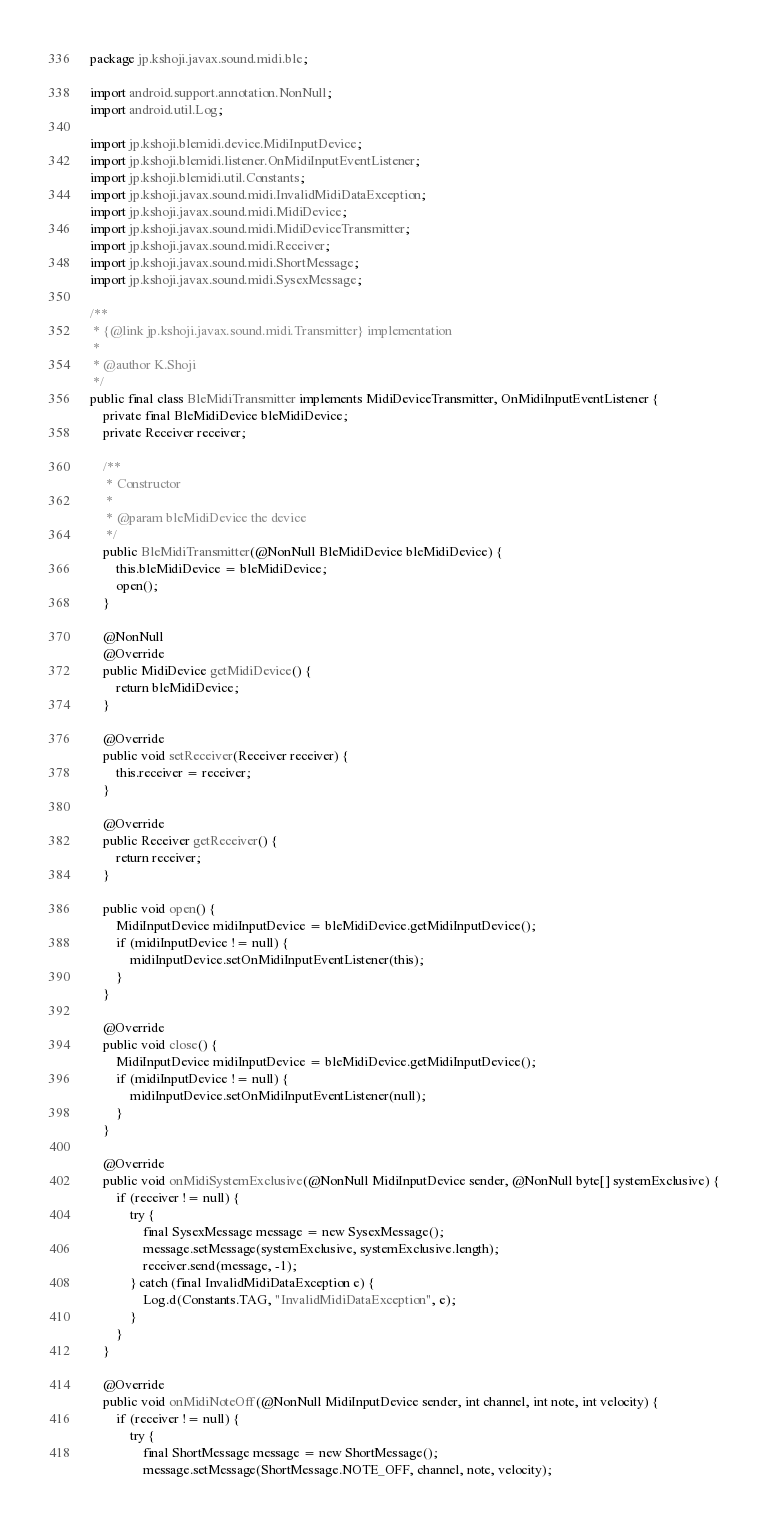Convert code to text. <code><loc_0><loc_0><loc_500><loc_500><_Java_>package jp.kshoji.javax.sound.midi.ble;

import android.support.annotation.NonNull;
import android.util.Log;

import jp.kshoji.blemidi.device.MidiInputDevice;
import jp.kshoji.blemidi.listener.OnMidiInputEventListener;
import jp.kshoji.blemidi.util.Constants;
import jp.kshoji.javax.sound.midi.InvalidMidiDataException;
import jp.kshoji.javax.sound.midi.MidiDevice;
import jp.kshoji.javax.sound.midi.MidiDeviceTransmitter;
import jp.kshoji.javax.sound.midi.Receiver;
import jp.kshoji.javax.sound.midi.ShortMessage;
import jp.kshoji.javax.sound.midi.SysexMessage;

/**
 * {@link jp.kshoji.javax.sound.midi.Transmitter} implementation
 *
 * @author K.Shoji
 */
public final class BleMidiTransmitter implements MidiDeviceTransmitter, OnMidiInputEventListener {
    private final BleMidiDevice bleMidiDevice;
    private Receiver receiver;

    /**
     * Constructor
     *
     * @param bleMidiDevice the device
     */
    public BleMidiTransmitter(@NonNull BleMidiDevice bleMidiDevice) {
        this.bleMidiDevice = bleMidiDevice;
        open();
    }

    @NonNull
    @Override
    public MidiDevice getMidiDevice() {
        return bleMidiDevice;
    }

    @Override
    public void setReceiver(Receiver receiver) {
        this.receiver = receiver;
    }

    @Override
    public Receiver getReceiver() {
        return receiver;
    }

    public void open() {
        MidiInputDevice midiInputDevice = bleMidiDevice.getMidiInputDevice();
        if (midiInputDevice != null) {
            midiInputDevice.setOnMidiInputEventListener(this);
        }
    }

    @Override
    public void close() {
        MidiInputDevice midiInputDevice = bleMidiDevice.getMidiInputDevice();
        if (midiInputDevice != null) {
            midiInputDevice.setOnMidiInputEventListener(null);
        }
    }

    @Override
    public void onMidiSystemExclusive(@NonNull MidiInputDevice sender, @NonNull byte[] systemExclusive) {
        if (receiver != null) {
            try {
                final SysexMessage message = new SysexMessage();
                message.setMessage(systemExclusive, systemExclusive.length);
                receiver.send(message, -1);
            } catch (final InvalidMidiDataException e) {
                Log.d(Constants.TAG, "InvalidMidiDataException", e);
            }
        }
    }

    @Override
    public void onMidiNoteOff(@NonNull MidiInputDevice sender, int channel, int note, int velocity) {
        if (receiver != null) {
            try {
                final ShortMessage message = new ShortMessage();
                message.setMessage(ShortMessage.NOTE_OFF, channel, note, velocity);</code> 